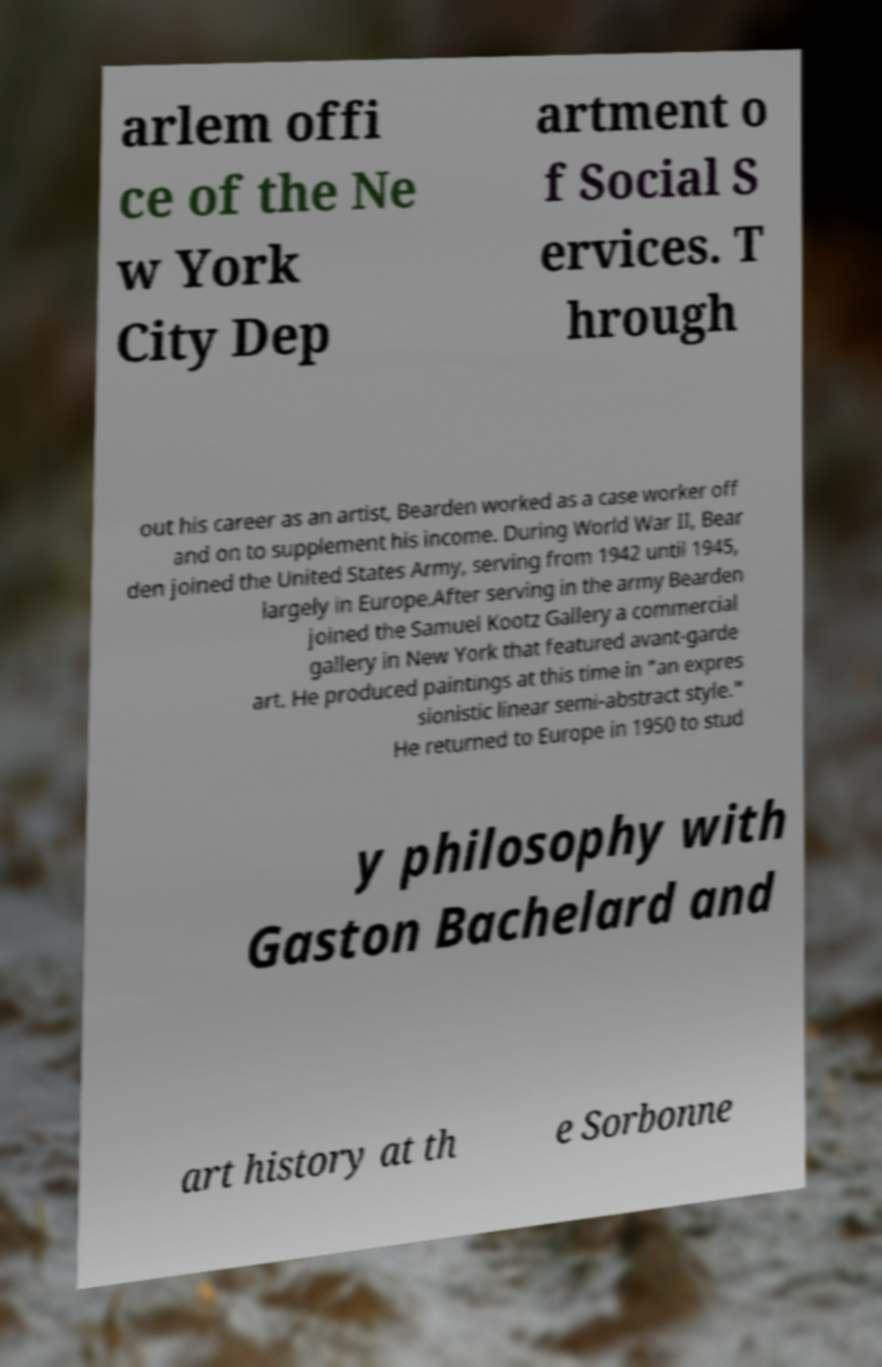I need the written content from this picture converted into text. Can you do that? arlem offi ce of the Ne w York City Dep artment o f Social S ervices. T hrough out his career as an artist, Bearden worked as a case worker off and on to supplement his income. During World War II, Bear den joined the United States Army, serving from 1942 until 1945, largely in Europe.After serving in the army Bearden joined the Samuel Kootz Gallery a commercial gallery in New York that featured avant-garde art. He produced paintings at this time in "an expres sionistic linear semi-abstract style." He returned to Europe in 1950 to stud y philosophy with Gaston Bachelard and art history at th e Sorbonne 